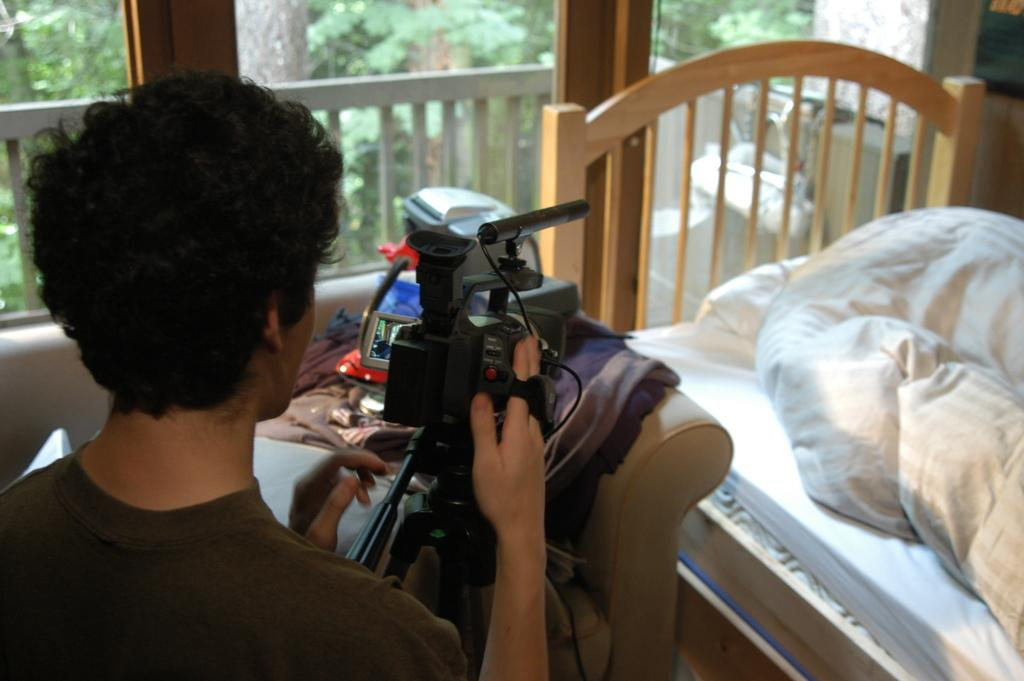Who is present in the image? There is a person in the image. What is the person wearing? The person is wearing a black shirt. What activity is the person engaged in? The person is recording a video with a camera. What type of furniture is in the image? There is a bed in the image. What color is the blanket on the bed? The bed has a white blanket on it. Where is the ocean visible in the image? There is no ocean present in the image. Is there a servant attending to the person in the image? There is no servant present in the image. 